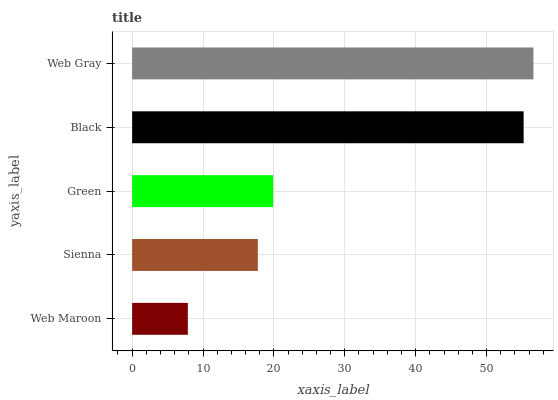Is Web Maroon the minimum?
Answer yes or no. Yes. Is Web Gray the maximum?
Answer yes or no. Yes. Is Sienna the minimum?
Answer yes or no. No. Is Sienna the maximum?
Answer yes or no. No. Is Sienna greater than Web Maroon?
Answer yes or no. Yes. Is Web Maroon less than Sienna?
Answer yes or no. Yes. Is Web Maroon greater than Sienna?
Answer yes or no. No. Is Sienna less than Web Maroon?
Answer yes or no. No. Is Green the high median?
Answer yes or no. Yes. Is Green the low median?
Answer yes or no. Yes. Is Web Gray the high median?
Answer yes or no. No. Is Web Maroon the low median?
Answer yes or no. No. 